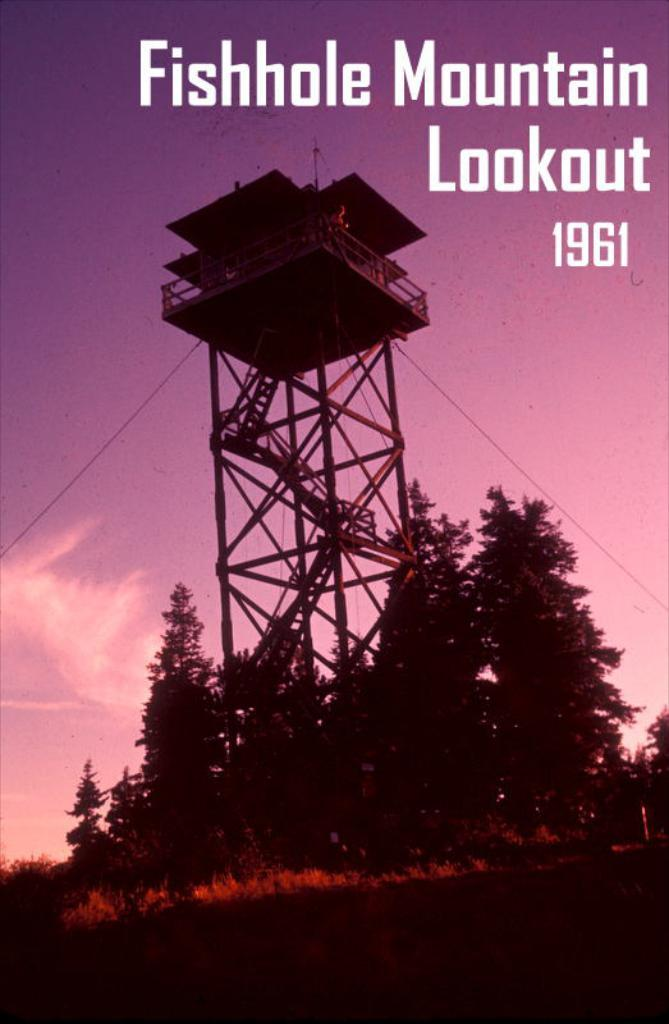What is featured on the poster in the image? The poster contains text. What type of vegetation can be seen in the image? There are trees visible in the image. What structure is present in the image? There is a tower in the image. What time of day is depicted in the image? The time of day is not depicted in the image, as there are no specific indicators of time. Can you tell me where the basin is located in the image? There is no basin present in the image. What event is being celebrated in the image? There is no event being celebrated in the image; it only features a poster, trees, and a tower. 